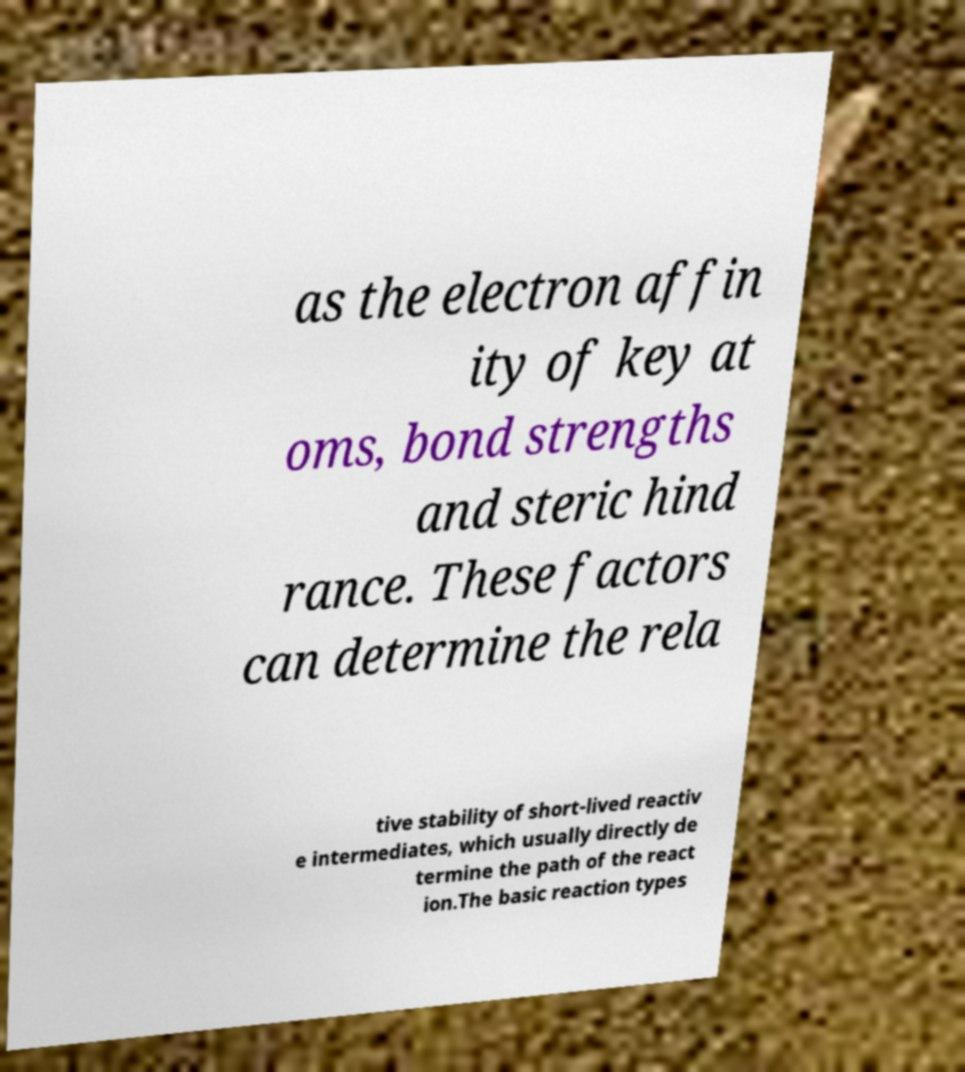There's text embedded in this image that I need extracted. Can you transcribe it verbatim? as the electron affin ity of key at oms, bond strengths and steric hind rance. These factors can determine the rela tive stability of short-lived reactiv e intermediates, which usually directly de termine the path of the react ion.The basic reaction types 